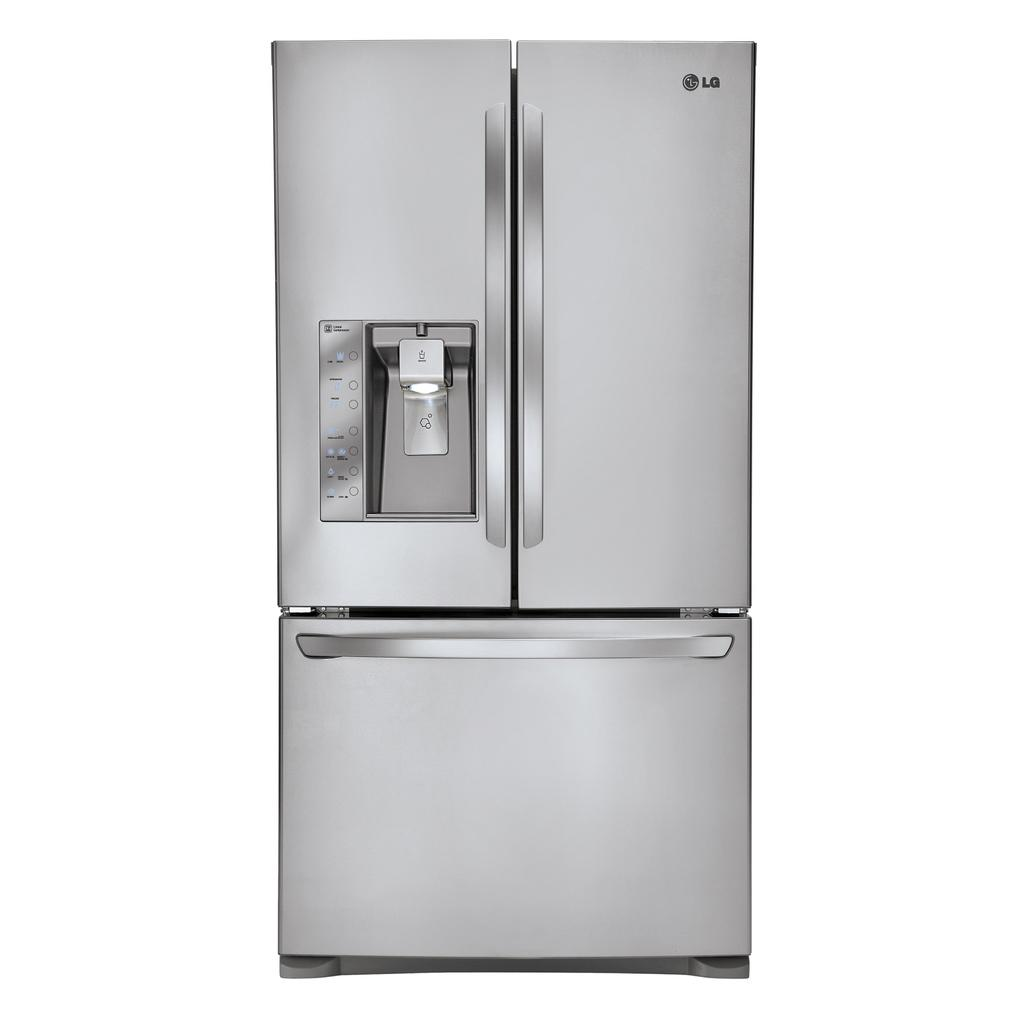<image>
Write a terse but informative summary of the picture. an lg double door fridge with a water machine on it 